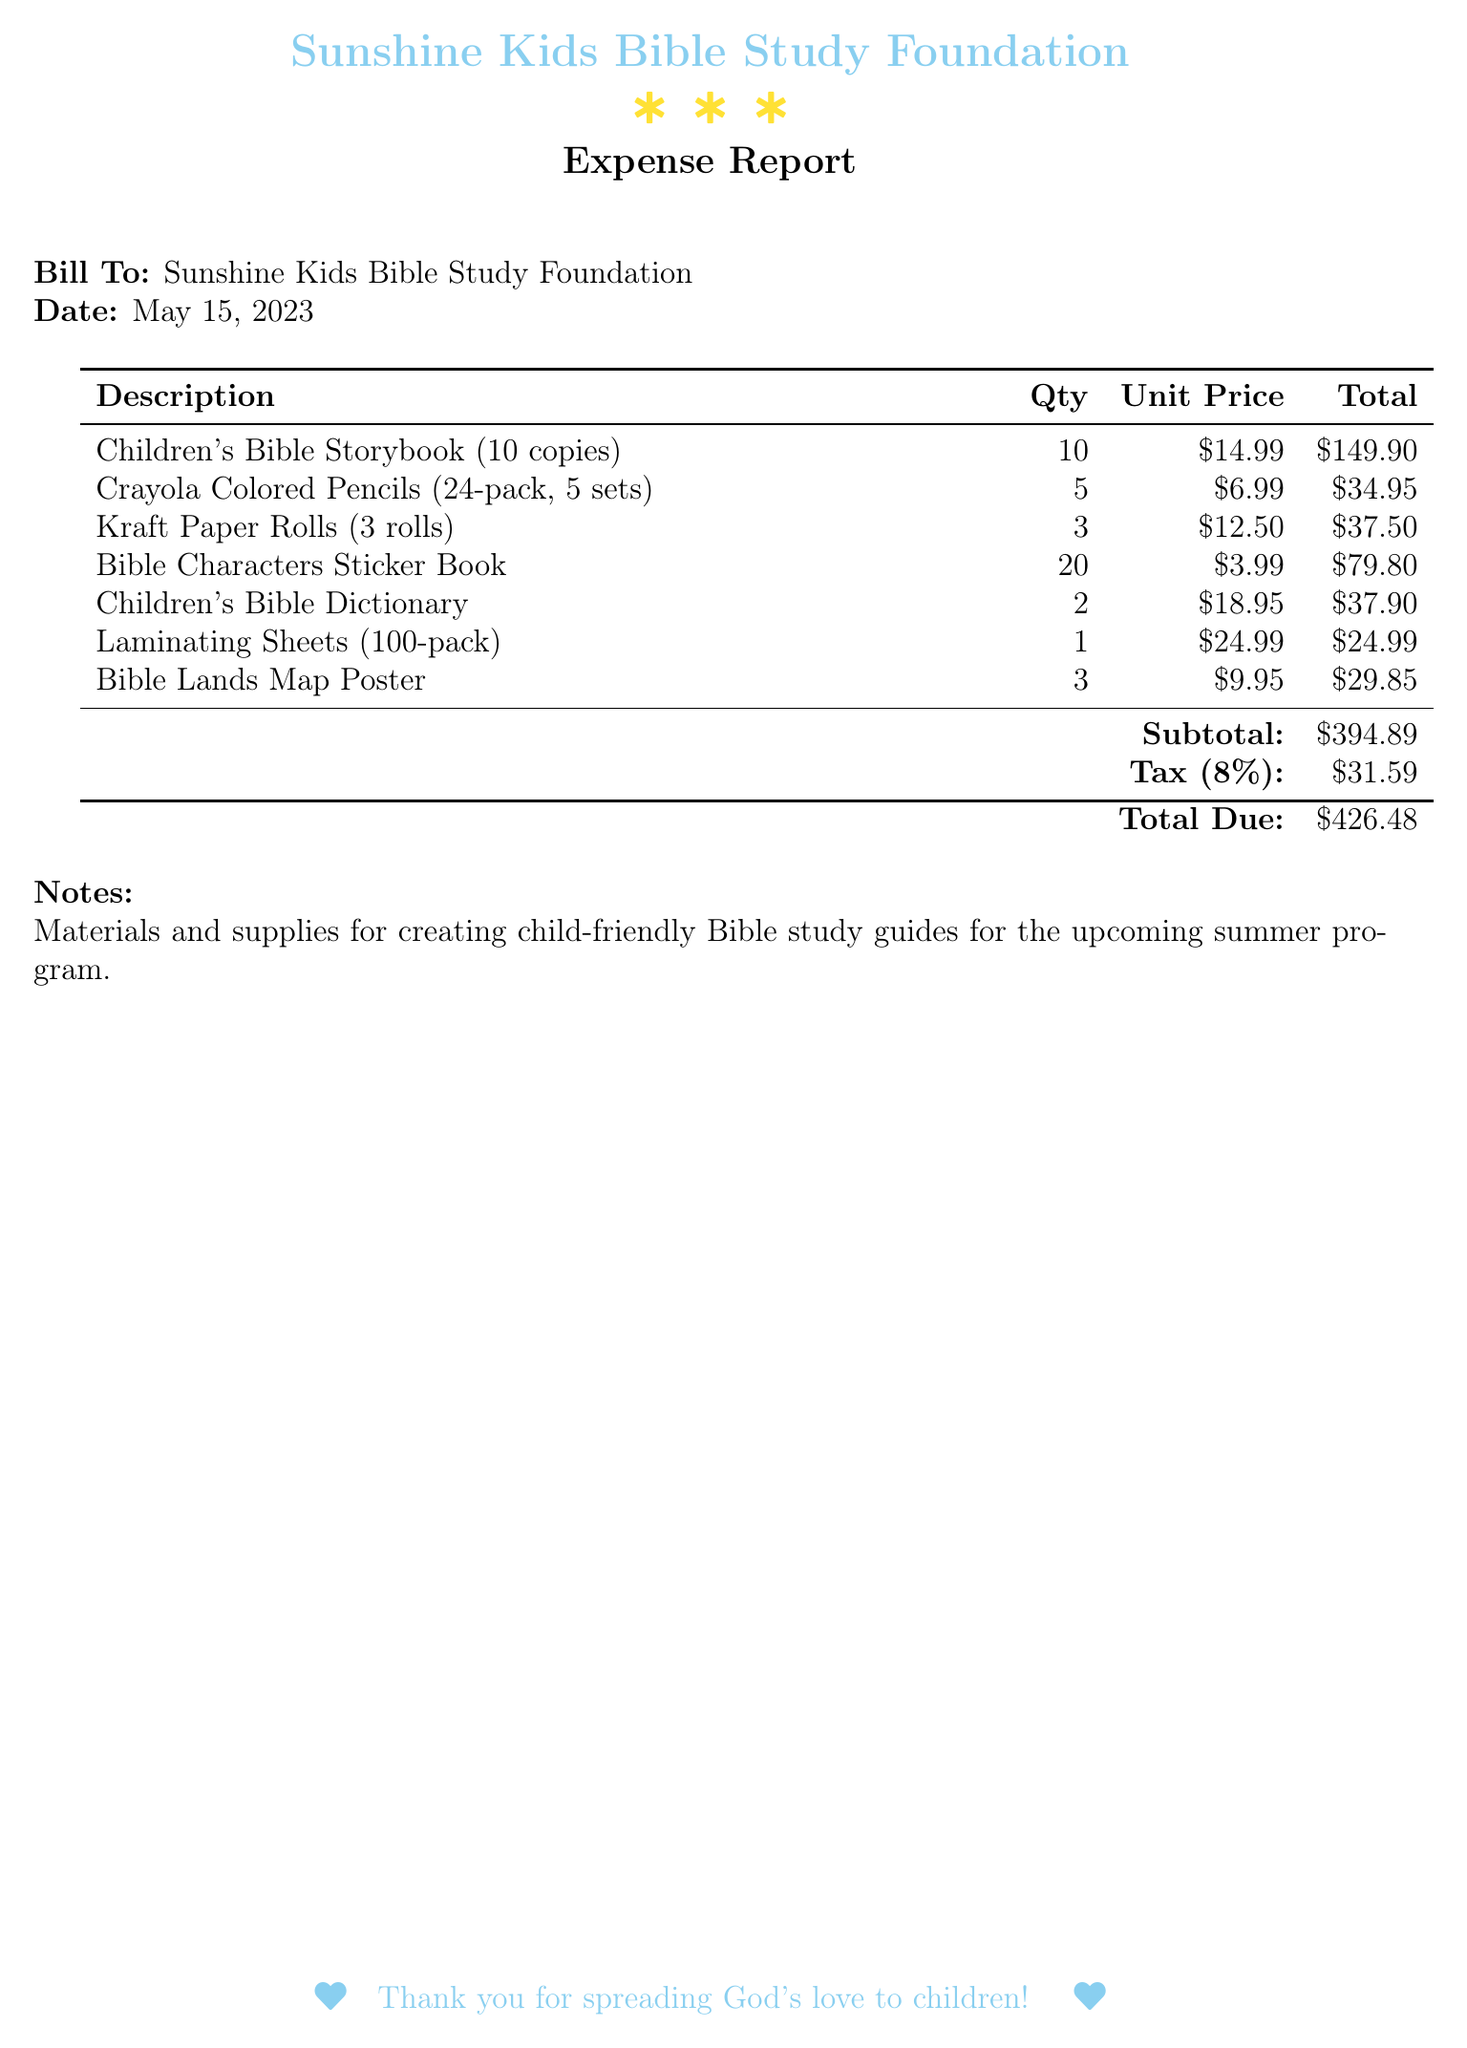What is the date of the expense report? The date listed in the expense report is a specific date that appears prominently.
Answer: May 15, 2023 What is the total due amount? The total due amount is clearly indicated at the bottom of the expense report.
Answer: $426.48 How many copies of the Children's Bible Storybook were purchased? The number of copies purchased is specified in the description of the item.
Answer: 10 What is the unit price of the Laminating Sheets? The unit price is listed next to the item in the table and represents the cost for one unit.
Answer: $24.99 What is the subtotal before tax? The subtotal is the sum of all items before tax is applied, which is shown in the calculations.
Answer: $394.89 What is the tax rate applied in the expense report? The tax rate can be found in the tax calculation section of the document.
Answer: 8% How many Bible Characters Sticker Books were ordered? The quantity of the sticker books is clearly mentioned in the report's itemized list.
Answer: 20 What is the total price for the Crayola Colored Pencils? The total price for the colored pencils is calculated and listed in the document.
Answer: $34.95 What was the purpose of the purchased materials? The purpose is specified in the notes section of the expense report.
Answer: Creating child-friendly Bible study guides 